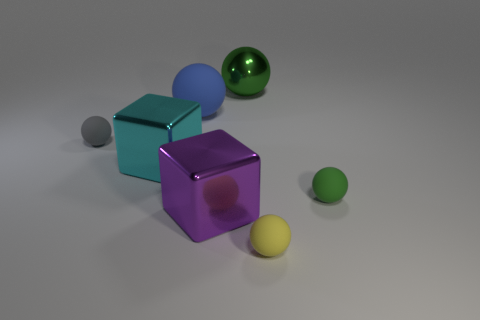Can you describe the composition of the objects in relation to each other? Certainly. The objects are arranged with a sense of balance yet randomness. A teal cube and a purple transparent cube are centered, with the former slightly overlapping the latter, creating a focal point. A green shiny sphere, a gray matte sphere, and a yellow matte ball are scattered around, each at a different distance from the camera, adding visual interest and depth to the arrangement.  Why might the different materials of the objects be significant? The variety of materials – matte, transparent, shiny – allows for a study in contrast and texture, demonstrating how light interacts with surfaces differently. This contrast in materials can evoke different emotional responses or serve practical purposes in design and visual arts to draw attention or guide the viewer's eye through the composition. 